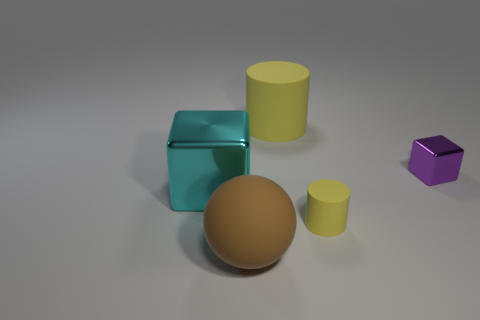There is a tiny object that is the same color as the big cylinder; what is it made of?
Your answer should be very brief. Rubber. What number of large objects are either cyan metallic objects or red matte objects?
Keep it short and to the point. 1. What is the color of the big cylinder?
Your answer should be compact. Yellow. There is a yellow object that is to the right of the large yellow cylinder; are there any shiny objects on the left side of it?
Offer a terse response. Yes. Is the number of large metallic objects that are to the left of the brown ball less than the number of big purple rubber spheres?
Make the answer very short. No. Is the large thing that is right of the big brown rubber object made of the same material as the big ball?
Ensure brevity in your answer.  Yes. What color is the other cube that is the same material as the cyan cube?
Your answer should be very brief. Purple. Is the number of purple blocks that are left of the large yellow object less than the number of tiny yellow cylinders that are left of the small yellow cylinder?
Provide a succinct answer. No. There is a rubber thing that is in front of the tiny matte object; does it have the same color as the metallic object that is on the left side of the tiny shiny thing?
Give a very brief answer. No. Are there any big cyan cubes that have the same material as the large yellow object?
Provide a short and direct response. No. 